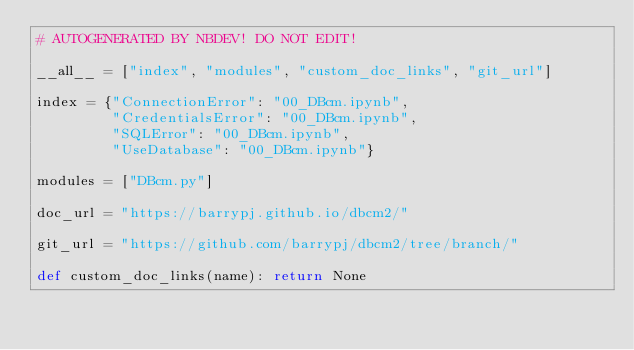<code> <loc_0><loc_0><loc_500><loc_500><_Python_># AUTOGENERATED BY NBDEV! DO NOT EDIT!

__all__ = ["index", "modules", "custom_doc_links", "git_url"]

index = {"ConnectionError": "00_DBcm.ipynb",
         "CredentialsError": "00_DBcm.ipynb",
         "SQLError": "00_DBcm.ipynb",
         "UseDatabase": "00_DBcm.ipynb"}

modules = ["DBcm.py"]

doc_url = "https://barrypj.github.io/dbcm2/"

git_url = "https://github.com/barrypj/dbcm2/tree/branch/"

def custom_doc_links(name): return None
</code> 